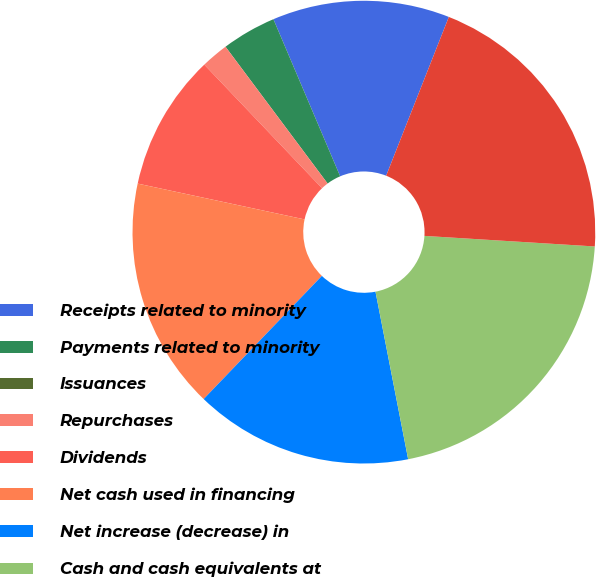Convert chart. <chart><loc_0><loc_0><loc_500><loc_500><pie_chart><fcel>Receipts related to minority<fcel>Payments related to minority<fcel>Issuances<fcel>Repurchases<fcel>Dividends<fcel>Net cash used in financing<fcel>Net increase (decrease) in<fcel>Cash and cash equivalents at<fcel>Homebuilding<nl><fcel>12.38%<fcel>3.81%<fcel>0.0%<fcel>1.91%<fcel>9.52%<fcel>16.19%<fcel>15.24%<fcel>20.95%<fcel>20.0%<nl></chart> 